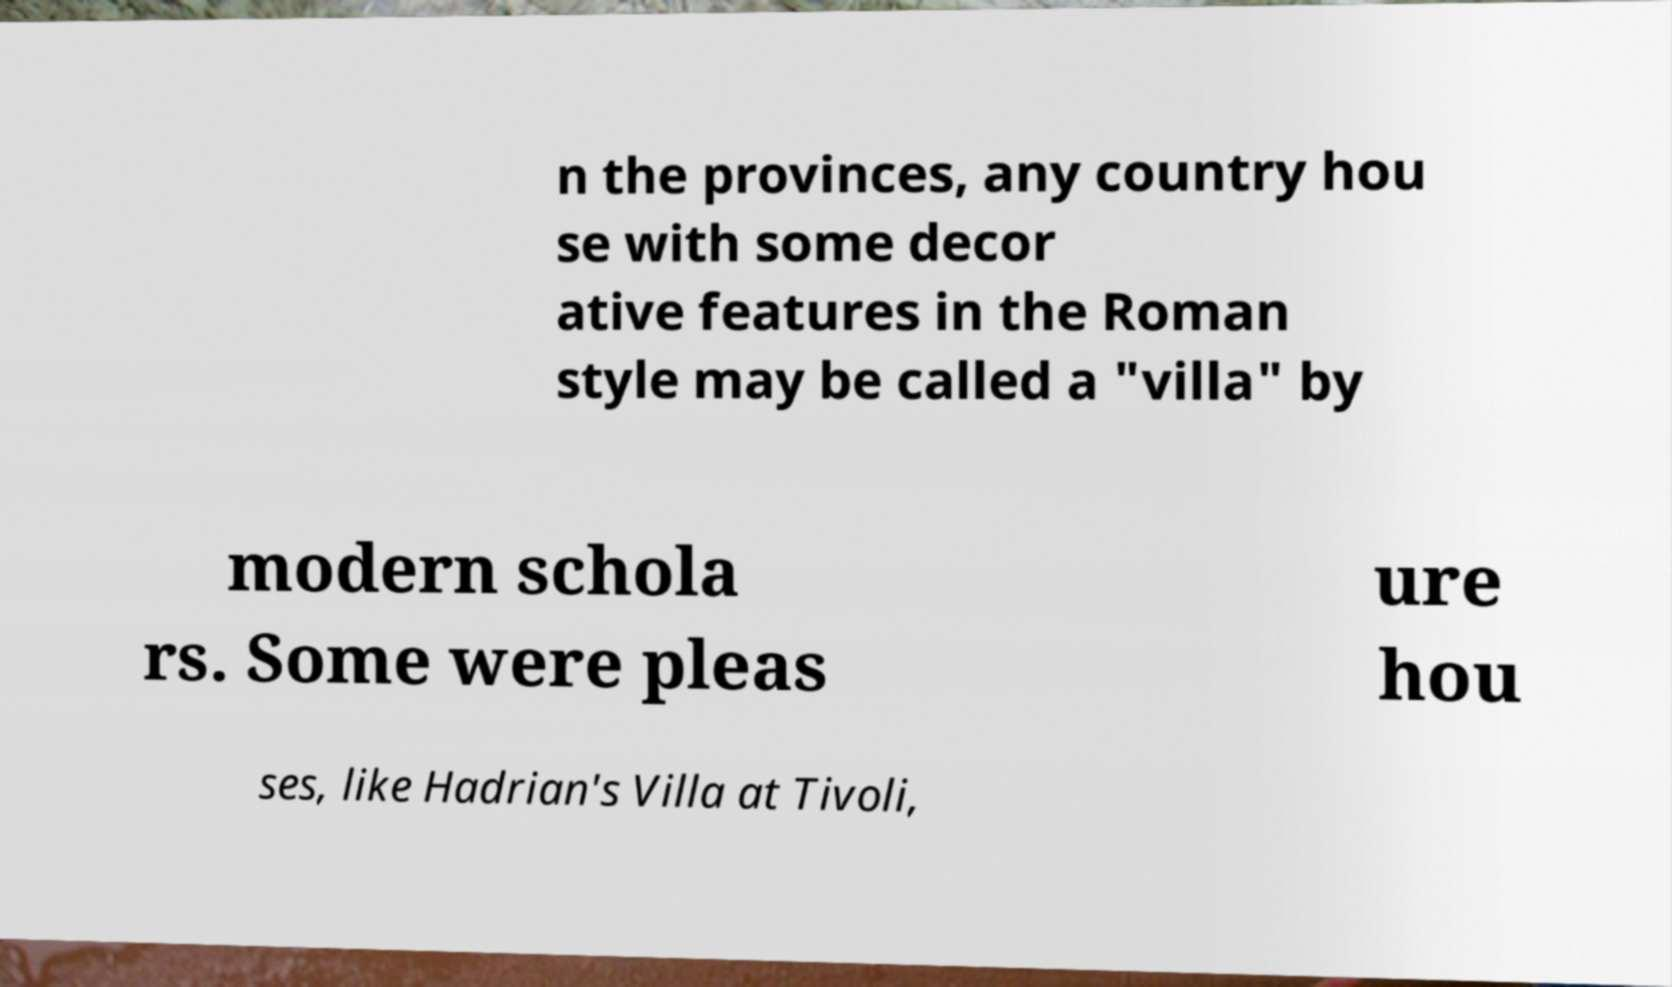What messages or text are displayed in this image? I need them in a readable, typed format. n the provinces, any country hou se with some decor ative features in the Roman style may be called a "villa" by modern schola rs. Some were pleas ure hou ses, like Hadrian's Villa at Tivoli, 